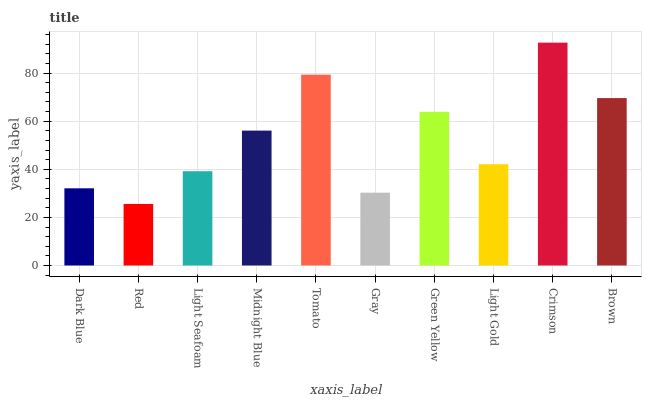Is Red the minimum?
Answer yes or no. Yes. Is Crimson the maximum?
Answer yes or no. Yes. Is Light Seafoam the minimum?
Answer yes or no. No. Is Light Seafoam the maximum?
Answer yes or no. No. Is Light Seafoam greater than Red?
Answer yes or no. Yes. Is Red less than Light Seafoam?
Answer yes or no. Yes. Is Red greater than Light Seafoam?
Answer yes or no. No. Is Light Seafoam less than Red?
Answer yes or no. No. Is Midnight Blue the high median?
Answer yes or no. Yes. Is Light Gold the low median?
Answer yes or no. Yes. Is Tomato the high median?
Answer yes or no. No. Is Tomato the low median?
Answer yes or no. No. 